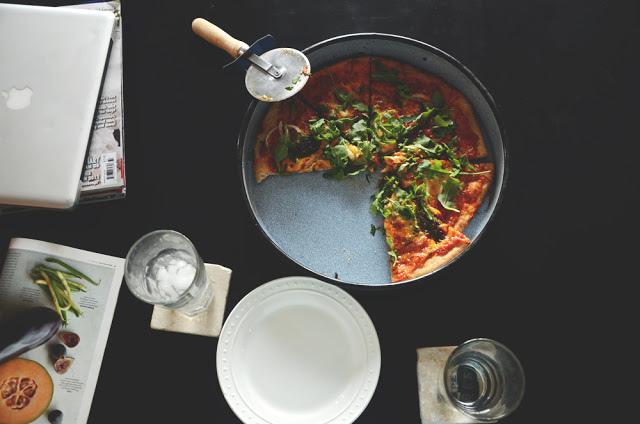What utensils are on the table?
Concise answer only. Pizza cutter. Is this pizza vegetable heavy?
Give a very brief answer. Yes. Is this a vegan meal?
Quick response, please. Yes. Is this a pet?
Keep it brief. No. What type of pizza is this?
Answer briefly. Spinach. What meal is most likely pictured here?
Short answer required. Pizza. 